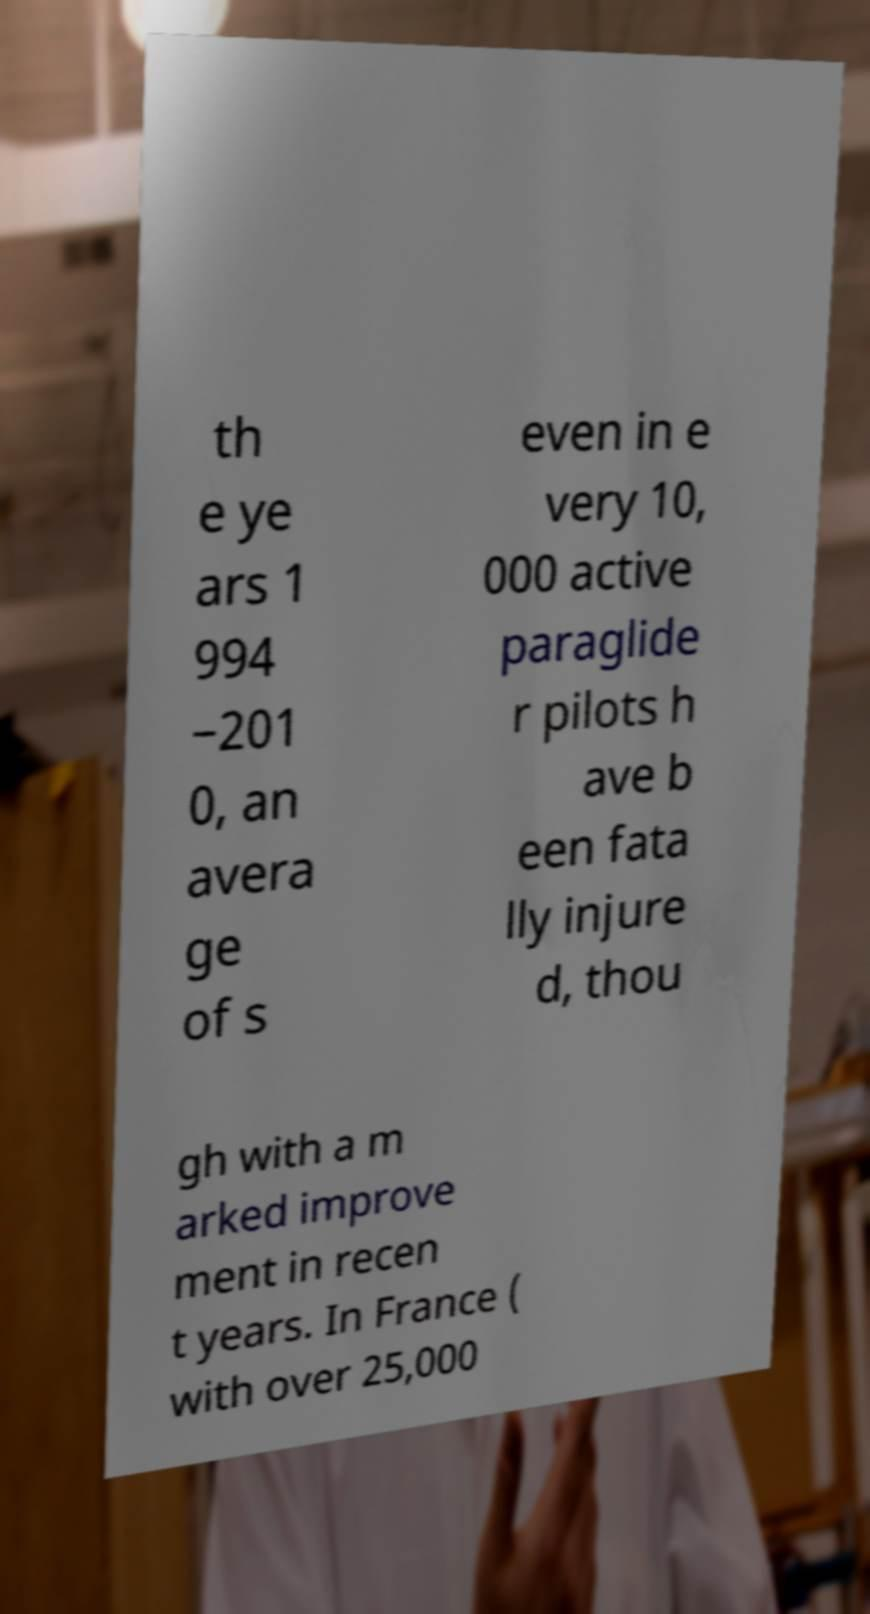Could you assist in decoding the text presented in this image and type it out clearly? th e ye ars 1 994 −201 0, an avera ge of s even in e very 10, 000 active paraglide r pilots h ave b een fata lly injure d, thou gh with a m arked improve ment in recen t years. In France ( with over 25,000 